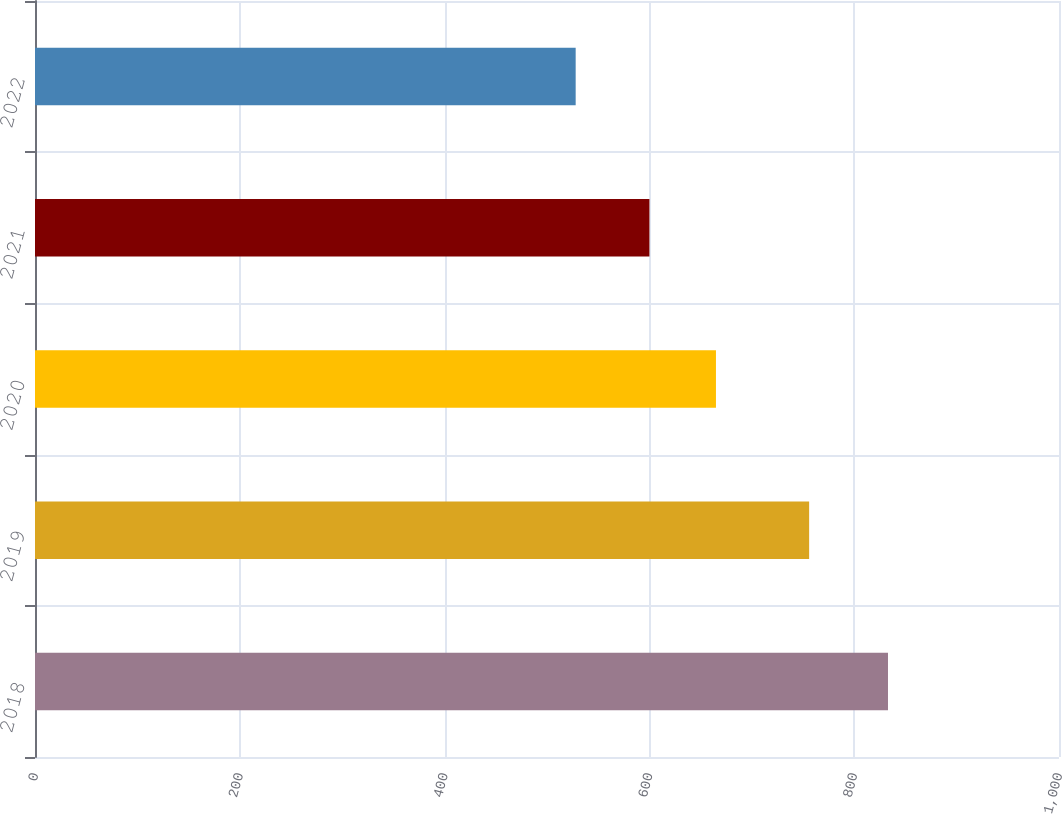Convert chart. <chart><loc_0><loc_0><loc_500><loc_500><bar_chart><fcel>2018<fcel>2019<fcel>2020<fcel>2021<fcel>2022<nl><fcel>833<fcel>756<fcel>665<fcel>600<fcel>528<nl></chart> 